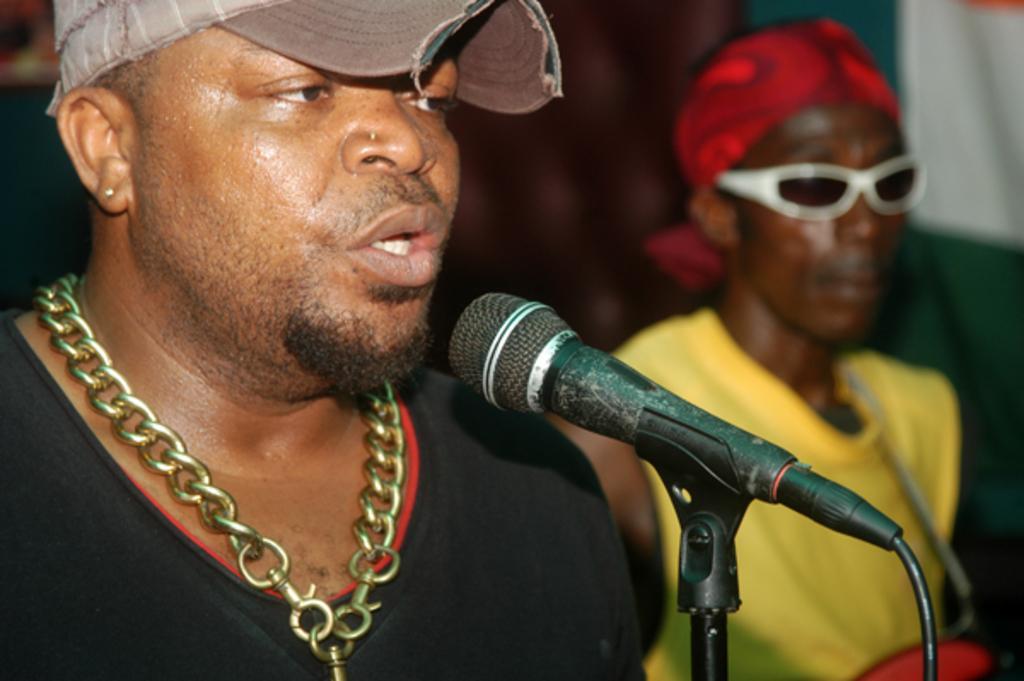Could you give a brief overview of what you see in this image? This image consists of two persons. One is in a black dress, another one is in yellow dress. The one who is in the black dress is wearing chain. He is talking something. There is a mic in front of him. 